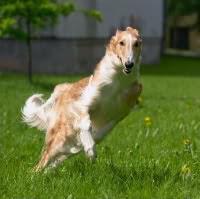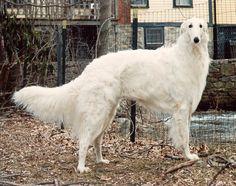The first image is the image on the left, the second image is the image on the right. Given the left and right images, does the statement "An image contains exactly two dogs." hold true? Answer yes or no. No. The first image is the image on the left, the second image is the image on the right. Assess this claim about the two images: "Each image contains exactly one hound, and the hound on the right is white and stands with its body turned rightward, while the dog on the left has orange-and-white fur.". Correct or not? Answer yes or no. Yes. 